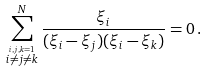<formula> <loc_0><loc_0><loc_500><loc_500>\sum _ { \stackrel { i , j , k = 1 } { i \neq j \neq k } } ^ { N } \frac { \xi _ { i } } { ( \xi _ { i } - \xi _ { j } ) ( \xi _ { i } - \xi _ { k } ) } = 0 \, .</formula> 